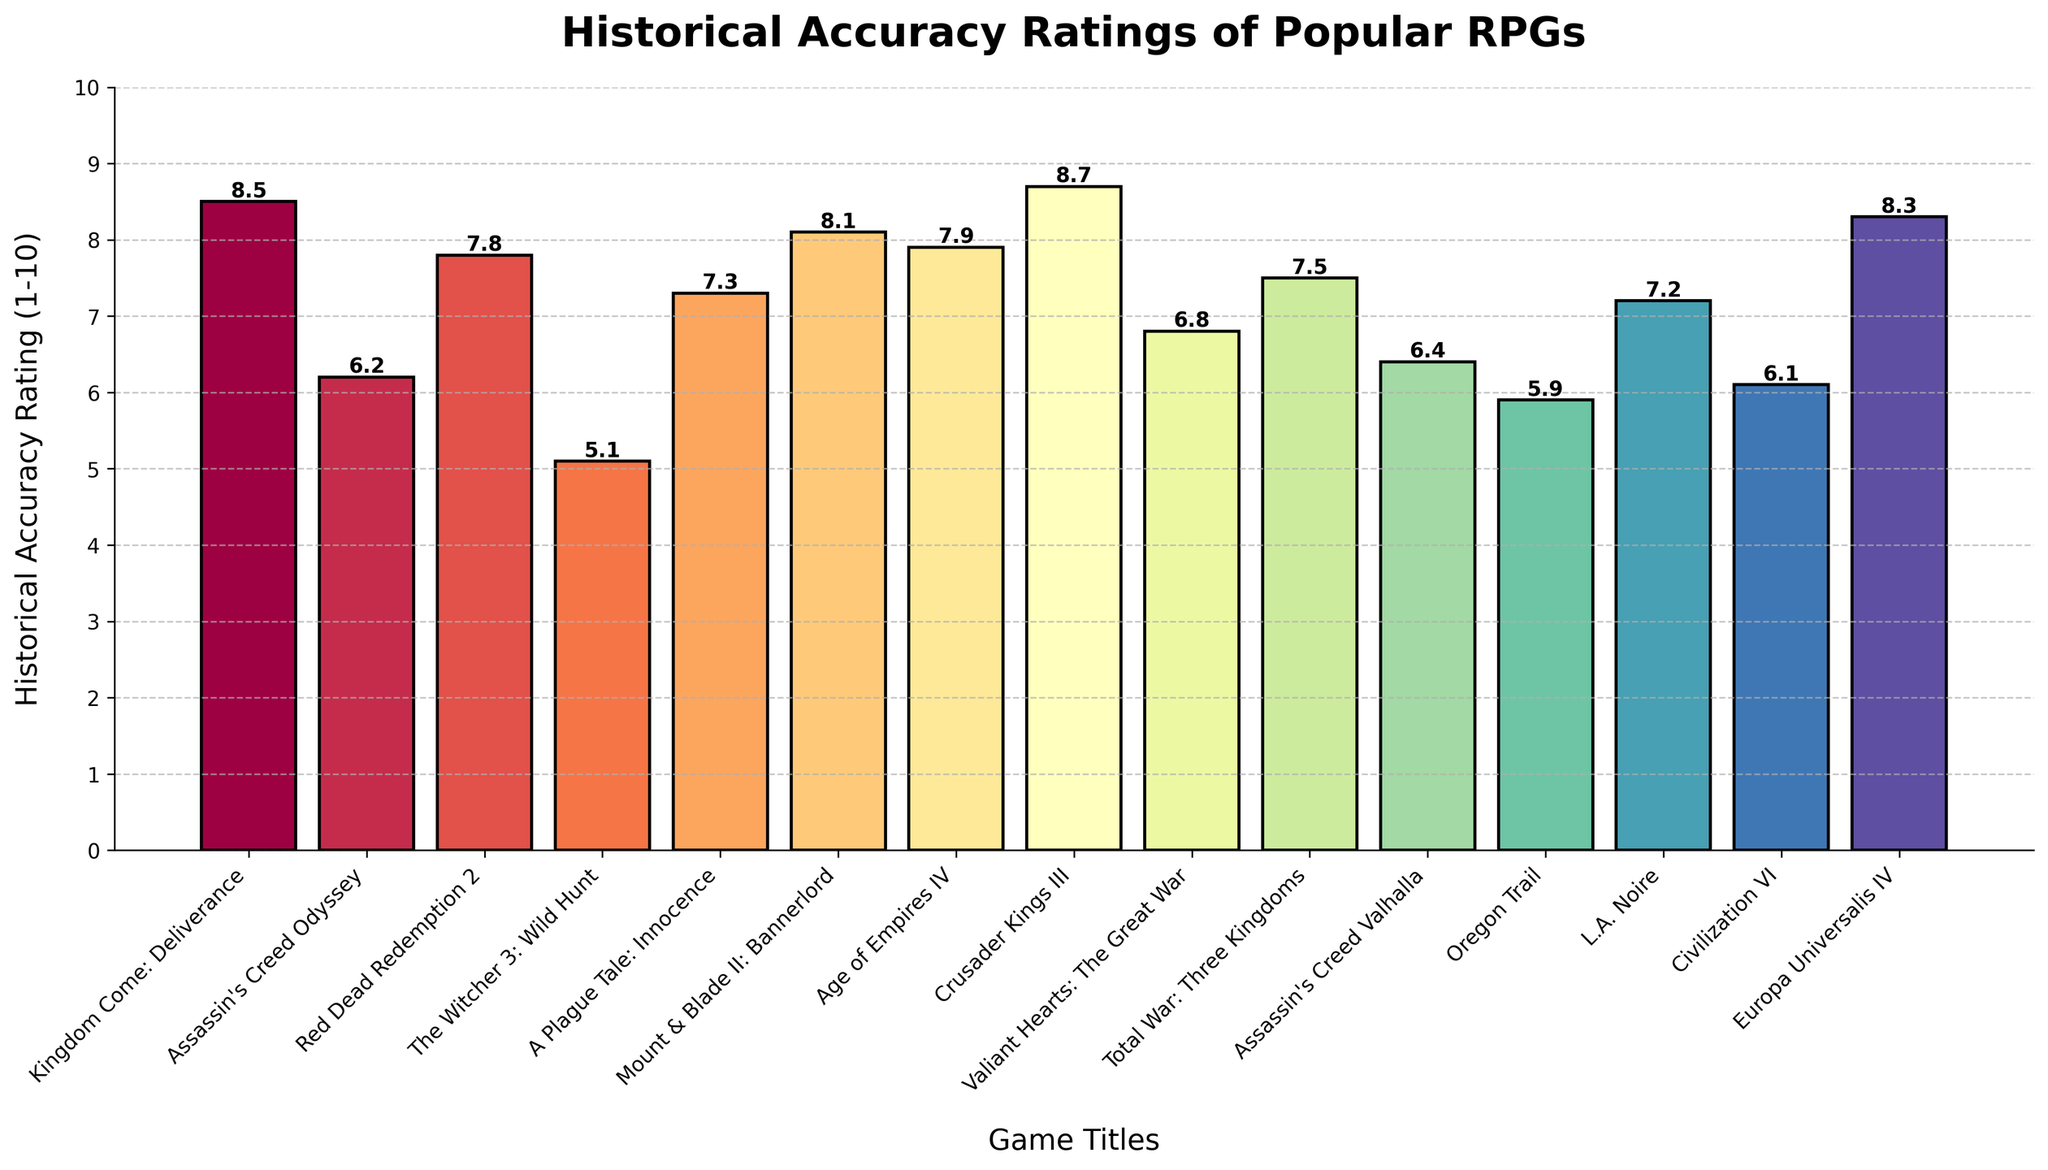Which game has the highest historical accuracy rating? Crusader Kings III has the tallest bar, indicating it has the highest historical accuracy rating.
Answer: Crusader Kings III Which game has the lowest historical accuracy rating? The Witcher 3: Wild Hunt has the shortest bar, denoting it has the lowest historical accuracy rating.
Answer: The Witcher 3: Wild Hunt What is the difference in historical accuracy rating between Assassin's Creed Odyssey and Assassin's Creed Valhalla? The rating for Assassin's Creed Odyssey is 6.2, and for Assassin's Creed Valhalla, it is 6.4. The difference is 6.4 - 6.2 = 0.2.
Answer: 0.2 Which games have historical accuracy ratings greater than 8? By observing the heights of the bars, Kingdom Come: Deliverance (8.5), Crusader Kings III (8.7), and Europa Universalis IV (8.3) are greater than 8.
Answer: Kingdom Come: Deliverance, Crusader Kings III, Europa Universalis IV How many games have a historical accuracy rating between 7 and 8? By counting the bars with heights between 7 and 8, there are five games: Red Dead Redemption 2 (7.8), A Plague Tale: Innocence (7.3), Age of Empires IV (7.9), Total War: Three Kingdoms (7.5), and L.A. Noire (7.2).
Answer: 5 What is the combined historical accuracy rating of Mount & Blade II: Bannerlord and Kingdom Come: Deliverance? The rating for Mount & Blade II: Bannerlord is 8.1, and for Kingdom Come: Deliverance is 8.5. The combined rating is 8.1 + 8.5 = 16.6.
Answer: 16.6 Which game has the nearest historical accuracy rating to 7.5? Total War: Three Kingdoms has a historical accuracy rating of 7.5.
Answer: Total War: Three Kingdoms Are there more games with a historical accuracy rating above 7.5 or below 7.5? There are 7 games with ratings above 7.5 and 8 games with ratings below 7.5. Therefore, there are more games below 7.5.
Answer: Below 7.5 